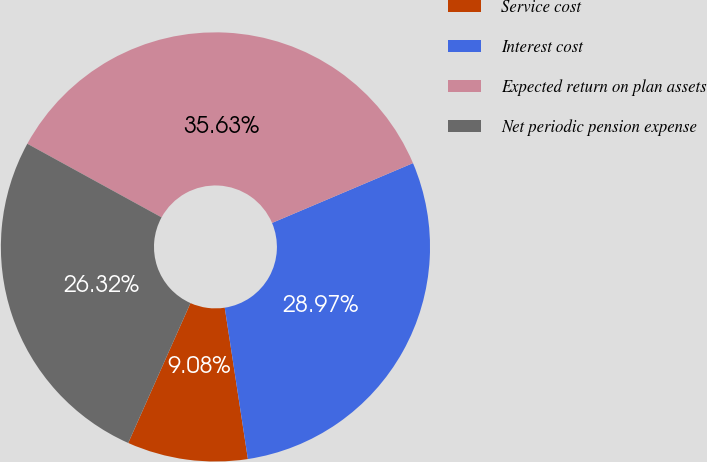Convert chart to OTSL. <chart><loc_0><loc_0><loc_500><loc_500><pie_chart><fcel>Service cost<fcel>Interest cost<fcel>Expected return on plan assets<fcel>Net periodic pension expense<nl><fcel>9.08%<fcel>28.97%<fcel>35.63%<fcel>26.32%<nl></chart> 